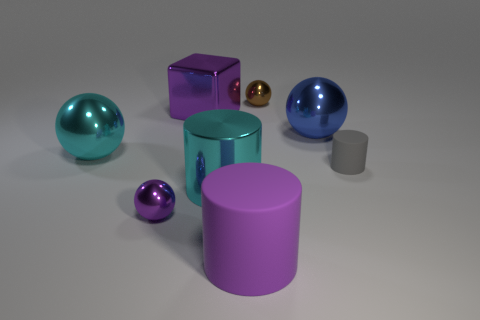There is a big block; is it the same color as the shiny ball that is in front of the gray thing?
Offer a terse response. Yes. What number of balls are either large purple metal things or big blue shiny objects?
Give a very brief answer. 1. The big sphere on the left side of the large cyan cylinder is what color?
Keep it short and to the point. Cyan. The purple rubber object that is the same size as the blue ball is what shape?
Your answer should be compact. Cylinder. There is a small matte cylinder; how many cyan things are behind it?
Make the answer very short. 1. How many things are spheres or large yellow metal cylinders?
Offer a very short reply. 4. There is a tiny object that is both on the right side of the purple metallic block and in front of the brown metallic object; what is its shape?
Ensure brevity in your answer.  Cylinder. How many green matte things are there?
Give a very brief answer. 0. What color is the block that is the same material as the cyan cylinder?
Ensure brevity in your answer.  Purple. Is the number of purple balls greater than the number of rubber cylinders?
Your answer should be compact. No. 